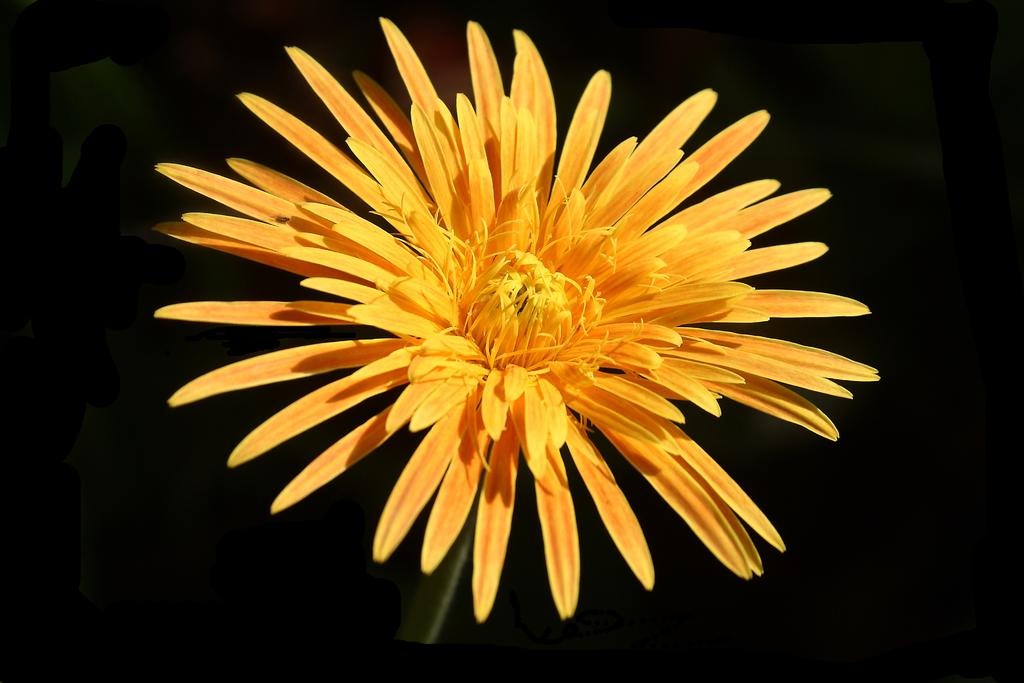What type of flower is in the image? There is a yellow flower in the image. What color is the background of the flower? The background of the flower is blue. What type of railway is visible in the image? There is no railway present in the image; it features a yellow flower with a blue background. What kind of drug can be seen in the image? There is no drug present in the image; it features a yellow flower with a blue background. 